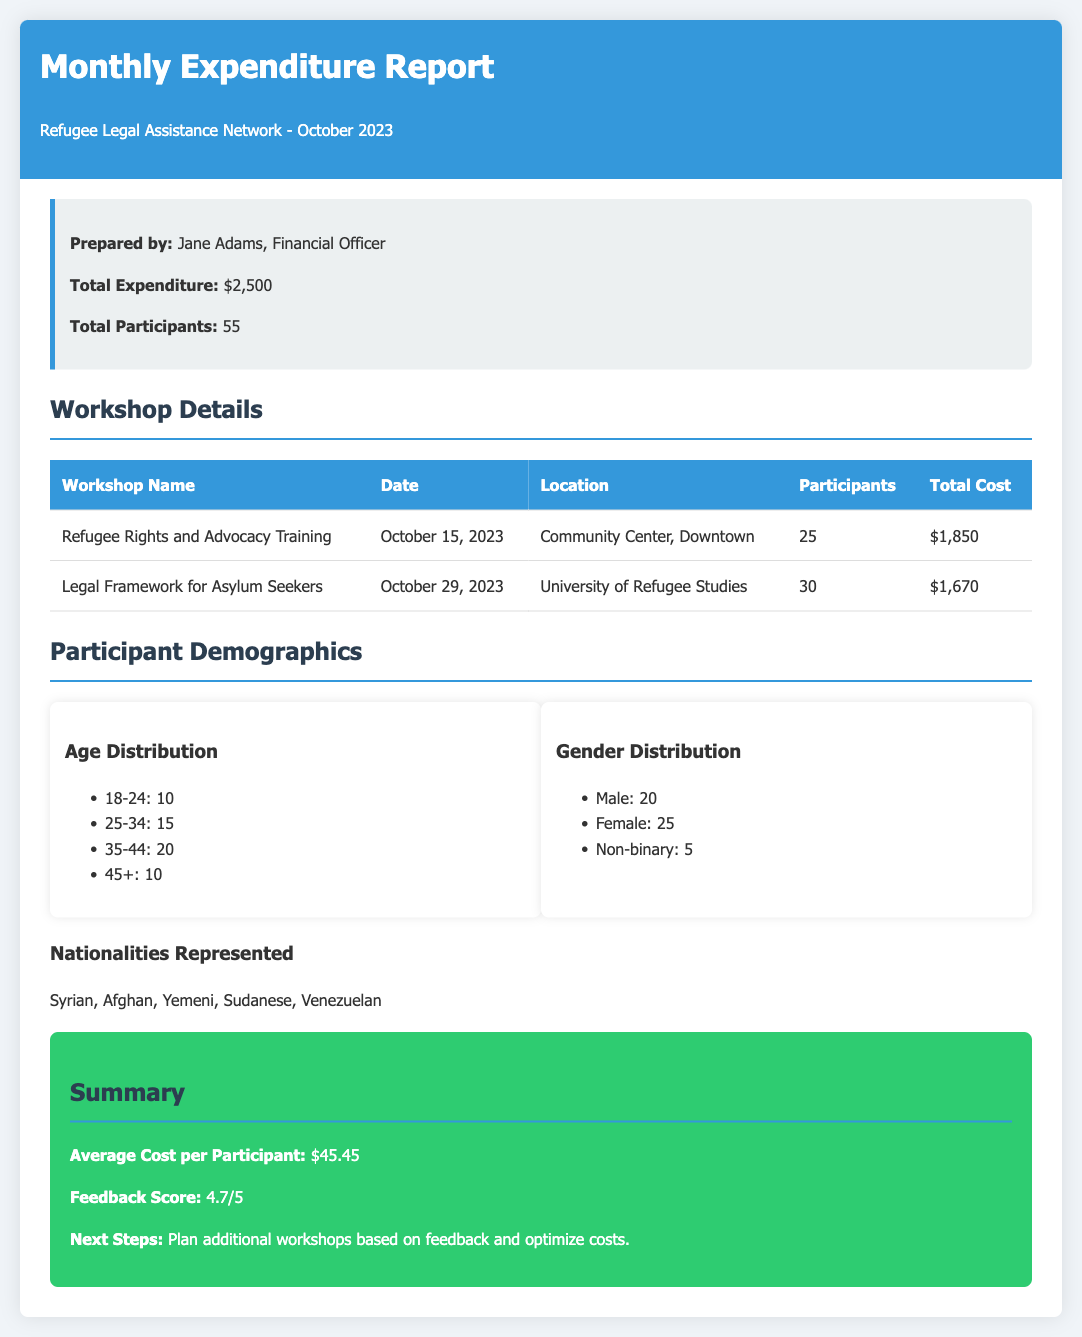What is the total expenditure? The total expenditure is stated in the document as $2,500.
Answer: $2,500 Who prepared the report? The report is prepared by Jane Adams, as mentioned in the info box.
Answer: Jane Adams What was the date of the "Refugee Rights and Advocacy Training" workshop? The date is specified in the workshop details as October 15, 2023.
Answer: October 15, 2023 How many participants attended the "Legal Framework for Asylum Seekers" workshop? The participant count for the workshop is shown in the table as 30.
Answer: 30 What is the average cost per participant? The average cost is summarized in the document, which is calculated as $2,500 divided by 55 participants.
Answer: $45.45 What age group had the highest number of participants? The age distribution shows that the 35-44 age group had the highest count with 20 participants.
Answer: 35-44 What is the feedback score for the workshops? The feedback score is highlighted in the summary section as 4.7 out of 5.
Answer: 4.7/5 What were the nationalities represented among participants? Nationalities are listed as Syrian, Afghan, Yemeni, Sudanese, and Venezuelan.
Answer: Syrian, Afghan, Yemeni, Sudanese, Venezuelan What is the total cost for the "Refugee Rights and Advocacy Training"? The total cost for this workshop is provided in the table as $1,850.
Answer: $1,850 